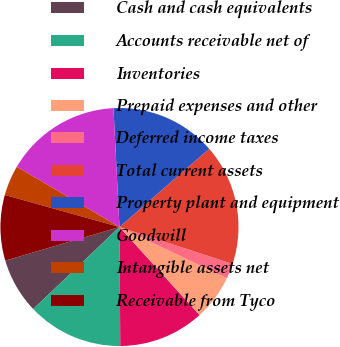<chart> <loc_0><loc_0><loc_500><loc_500><pie_chart><fcel>Cash and cash equivalents<fcel>Accounts receivable net of<fcel>Inventories<fcel>Prepaid expenses and other<fcel>Deferred income taxes<fcel>Total current assets<fcel>Property plant and equipment<fcel>Goodwill<fcel>Intangible assets net<fcel>Receivable from Tyco<nl><fcel>7.54%<fcel>13.01%<fcel>11.64%<fcel>6.17%<fcel>2.06%<fcel>16.44%<fcel>14.38%<fcel>15.75%<fcel>4.11%<fcel>8.9%<nl></chart> 